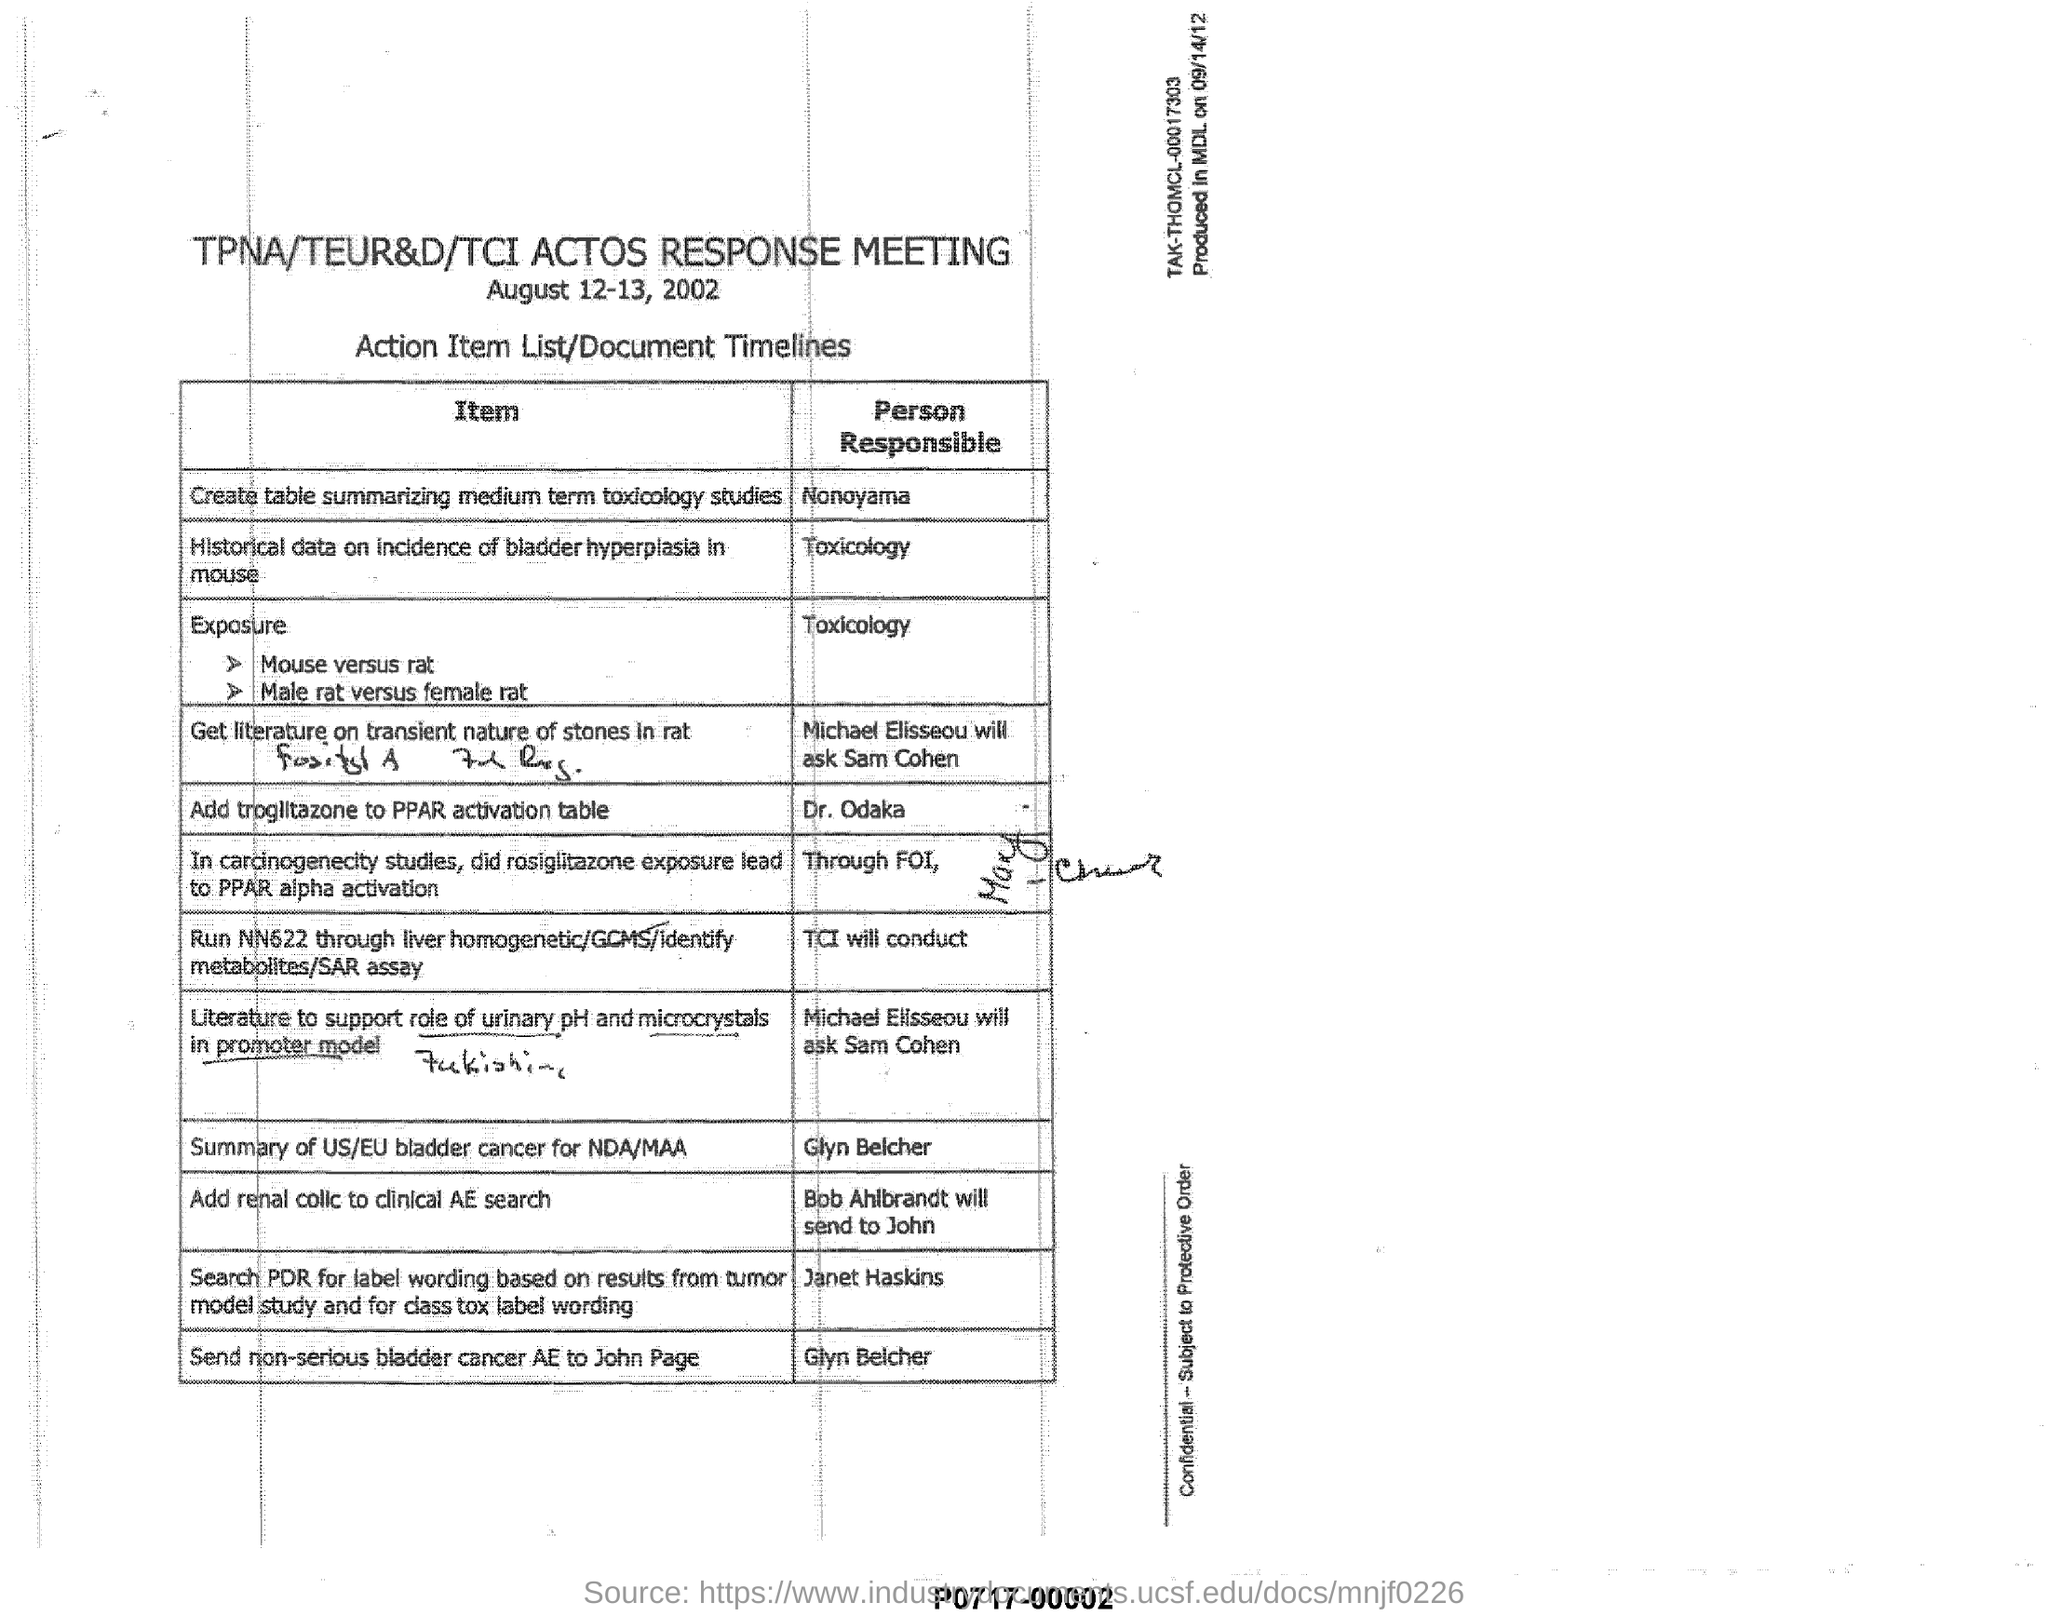Specify some key components in this picture. The heading of the document is "TPNA/TEUR&D/TCI ACTOS RESPONSE MEETING. The text that is written immediately below the date is a list of action items and timelines for a document. The item that shows the person responsible for sending the item to John is Bob Ahlbrandt. It is requested to add renal colic to the clinical Advanced Encounter Search. The date mentioned is August 12-13, 2002. 